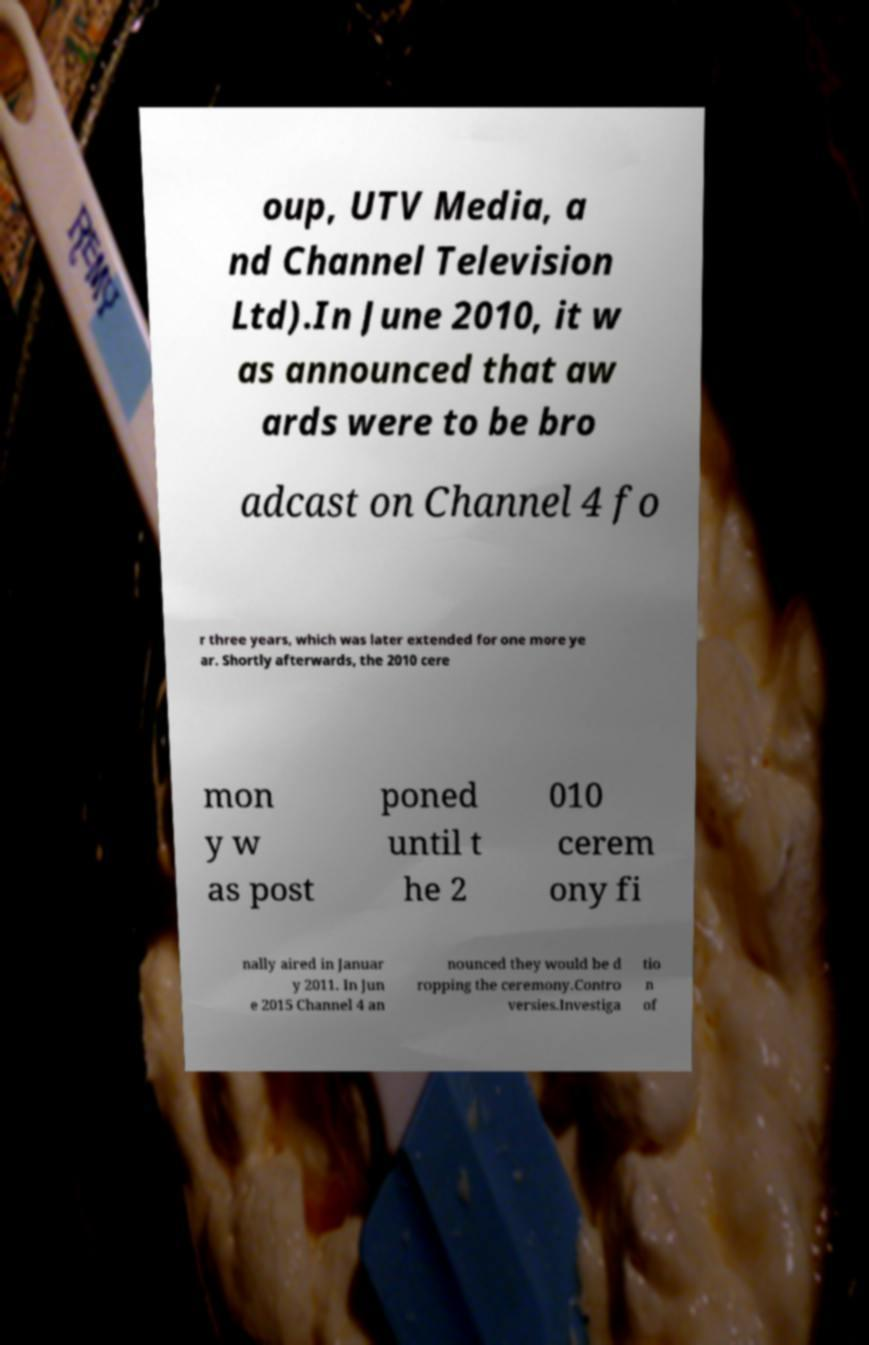What messages or text are displayed in this image? I need them in a readable, typed format. oup, UTV Media, a nd Channel Television Ltd).In June 2010, it w as announced that aw ards were to be bro adcast on Channel 4 fo r three years, which was later extended for one more ye ar. Shortly afterwards, the 2010 cere mon y w as post poned until t he 2 010 cerem ony fi nally aired in Januar y 2011. In Jun e 2015 Channel 4 an nounced they would be d ropping the ceremony.Contro versies.Investiga tio n of 